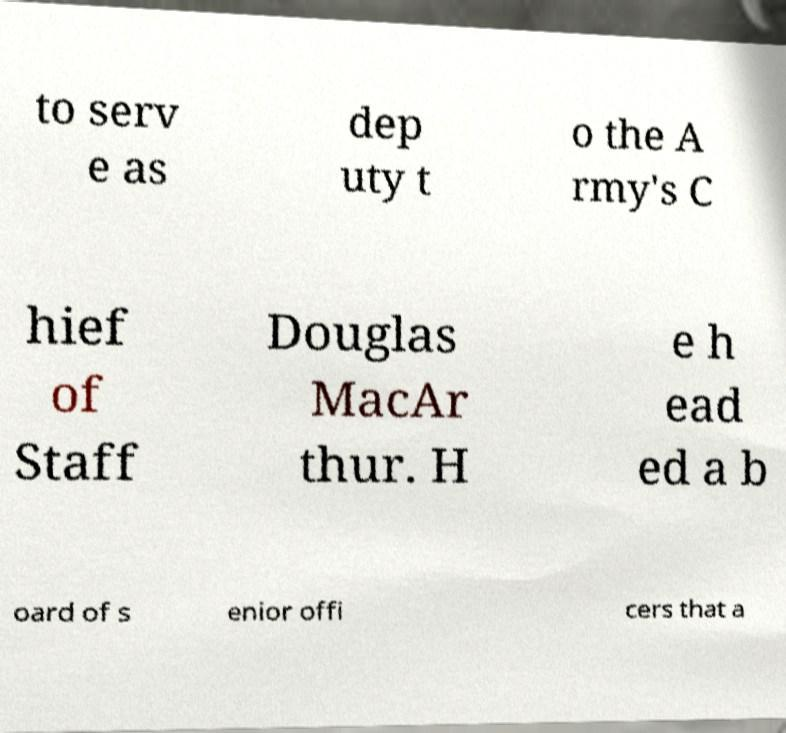Could you extract and type out the text from this image? to serv e as dep uty t o the A rmy's C hief of Staff Douglas MacAr thur. H e h ead ed a b oard of s enior offi cers that a 